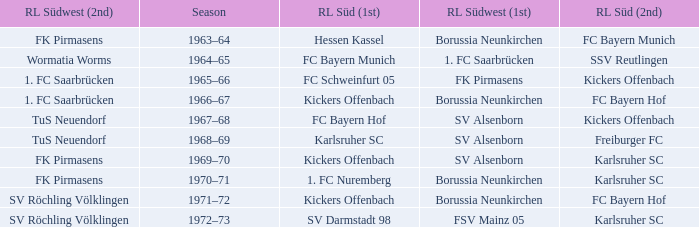Who was RL Süd (1st) when FK Pirmasens was RL Südwest (1st)? FC Schweinfurt 05. 